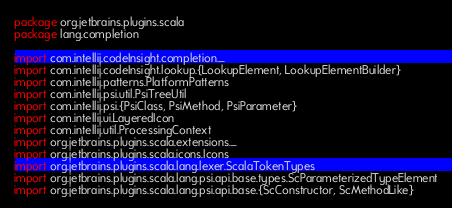Convert code to text. <code><loc_0><loc_0><loc_500><loc_500><_Scala_>package org.jetbrains.plugins.scala
package lang.completion

import com.intellij.codeInsight.completion._
import com.intellij.codeInsight.lookup.{LookupElement, LookupElementBuilder}
import com.intellij.patterns.PlatformPatterns
import com.intellij.psi.util.PsiTreeUtil
import com.intellij.psi.{PsiClass, PsiMethod, PsiParameter}
import com.intellij.ui.LayeredIcon
import com.intellij.util.ProcessingContext
import org.jetbrains.plugins.scala.extensions._
import org.jetbrains.plugins.scala.icons.Icons
import org.jetbrains.plugins.scala.lang.lexer.ScalaTokenTypes
import org.jetbrains.plugins.scala.lang.psi.api.base.types.ScParameterizedTypeElement
import org.jetbrains.plugins.scala.lang.psi.api.base.{ScConstructor, ScMethodLike}</code> 